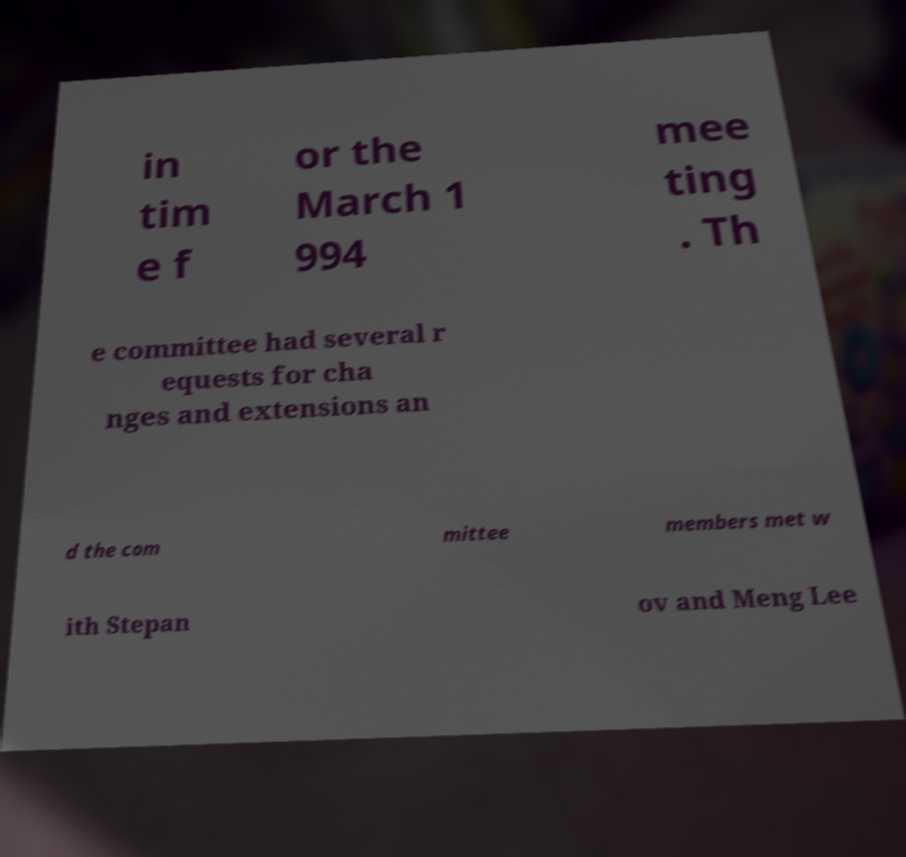I need the written content from this picture converted into text. Can you do that? in tim e f or the March 1 994 mee ting . Th e committee had several r equests for cha nges and extensions an d the com mittee members met w ith Stepan ov and Meng Lee 